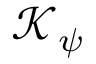<formula> <loc_0><loc_0><loc_500><loc_500>\mathcal { K } _ { \psi }</formula> 